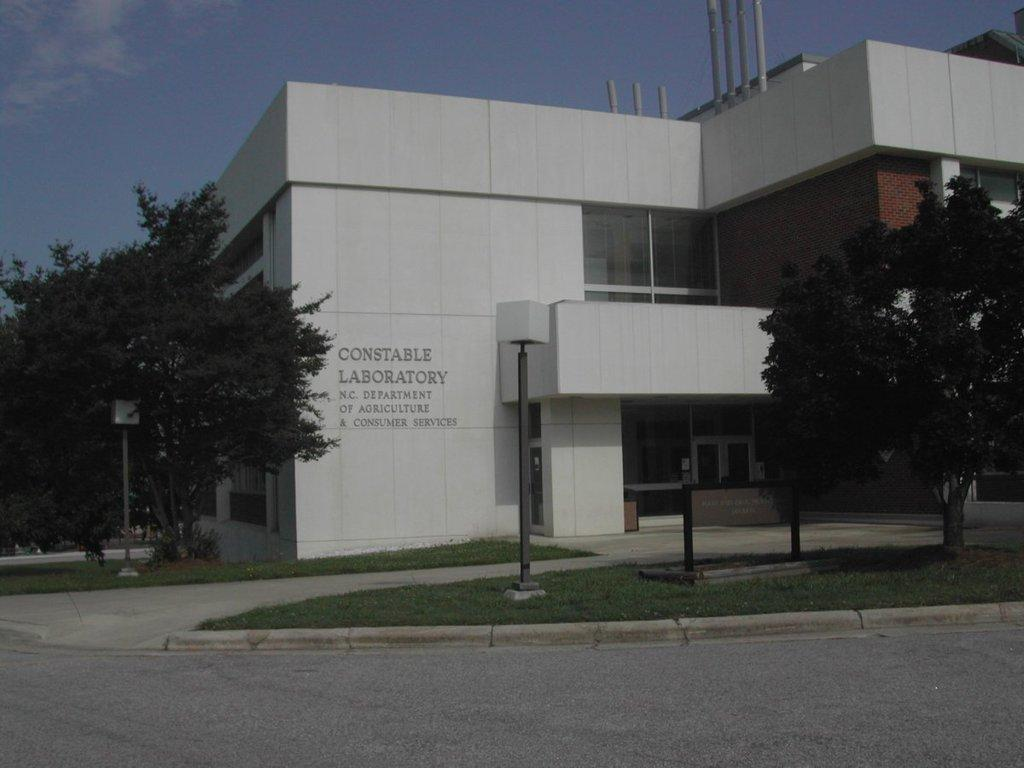What type of surface can be seen in the image? There is a road in the image. What type of vegetation is present in the image? There is grass and trees in the image. What type of structures can be seen in the image? There are fed poles and a white-colored building in the image. What type of illumination is present in the image? There are lights in the image. What is visible in the background of the image? The sky is visible in the background of the image. Is there any text or writing present in the image? Yes, there is text or writing present in the image. What type of thread is used to create the spot on the building in the image? There is no spot on the building in the image, and therefore no thread is involved. What time of day is depicted in the image? The provided facts do not give information about the time of day, so it cannot be determined from the image. 